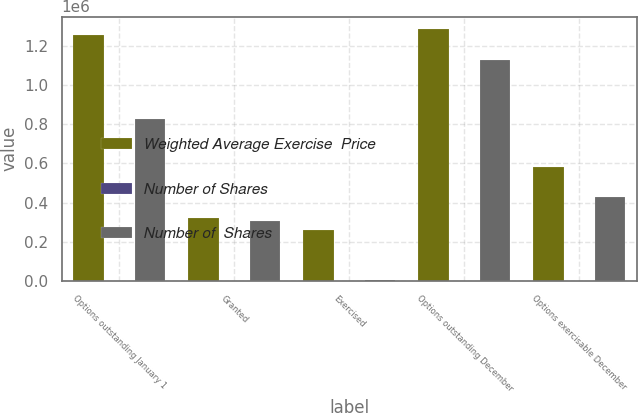Convert chart to OTSL. <chart><loc_0><loc_0><loc_500><loc_500><stacked_bar_chart><ecel><fcel>Options outstanding January 1<fcel>Granted<fcel>Exercised<fcel>Options outstanding December<fcel>Options exercisable December<nl><fcel>Weighted Average Exercise  Price<fcel>1.25778e+06<fcel>319275<fcel>262314<fcel>1.28566e+06<fcel>582361<nl><fcel>Number of Shares<fcel>50.3<fcel>78.54<fcel>45.76<fcel>58.02<fcel>50.37<nl><fcel>Number of  Shares<fcel>827000<fcel>306300<fcel>5850<fcel>1.12745e+06<fcel>430625<nl></chart> 